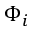<formula> <loc_0><loc_0><loc_500><loc_500>\Phi _ { i }</formula> 